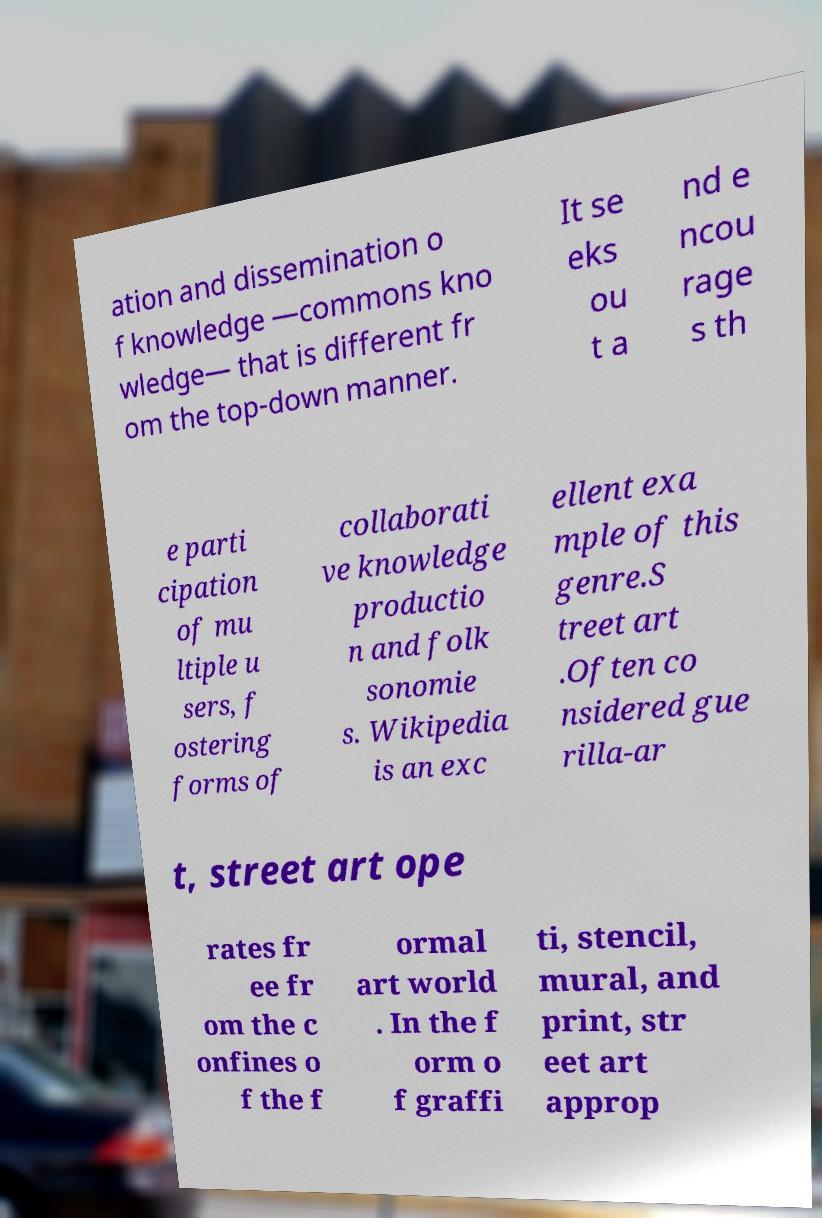Could you assist in decoding the text presented in this image and type it out clearly? ation and dissemination o f knowledge —commons kno wledge— that is different fr om the top-down manner. It se eks ou t a nd e ncou rage s th e parti cipation of mu ltiple u sers, f ostering forms of collaborati ve knowledge productio n and folk sonomie s. Wikipedia is an exc ellent exa mple of this genre.S treet art .Often co nsidered gue rilla-ar t, street art ope rates fr ee fr om the c onfines o f the f ormal art world . In the f orm o f graffi ti, stencil, mural, and print, str eet art approp 